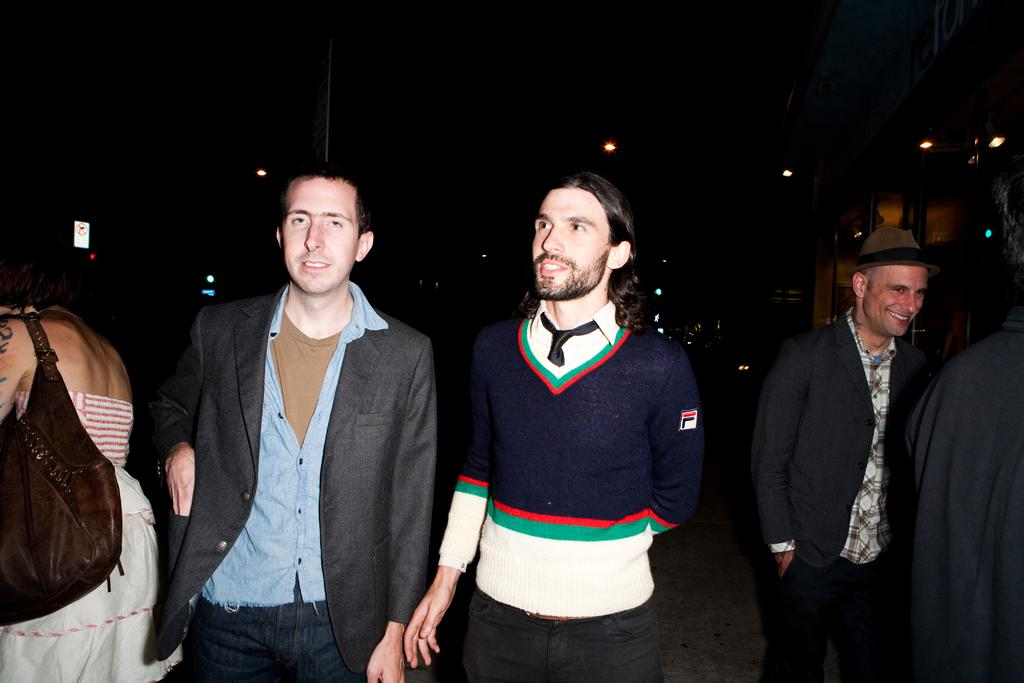How many people are in the image? There are people in the image, but the exact number is not specified. Can you describe the clothing of one of the people? One person is wearing a hat. What can be seen in the image that provides illumination? There are lights in the image. What is located on the right side of the image? There is an object on the right side of the image. What type of pollution can be seen in the image? There is no reference to pollution in the image, so it cannot be determined from the facts provided. 